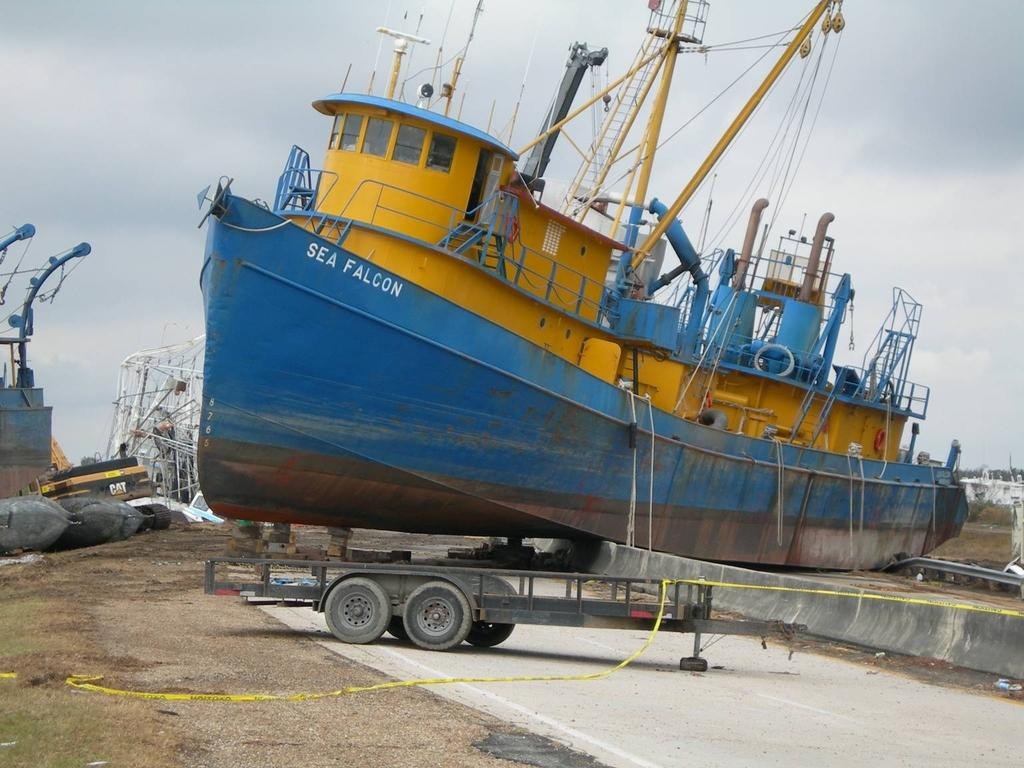Provide a one-sentence caption for the provided image. A ship called the Sea Falcon has been run onto ground. 